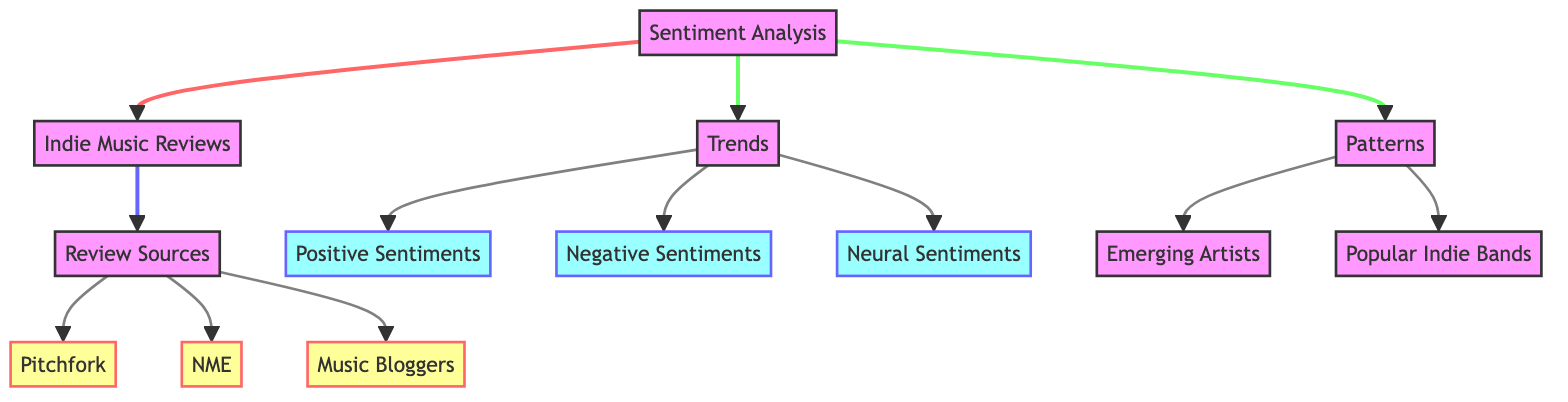What's the main focus of the diagram? The diagram centers on Sentiment Analysis and its relationship with Indie Music Reviews. The central node is "Sentiment Analysis," which connects to "Indie Music Reviews," illustrating this as the primary subject of the analysis.
Answer: Sentiment Analysis How many sources are identified in the diagram? The diagram lists three specific sources under the "Review Sources" node: Pitchfork, NME, and Music Bloggers. By counting these, we find the total to be three.
Answer: 3 What types of sentiments are detailed under "Trends"? Under the "Trends" node, three types of sentiments are indicated: Positive Sentiments, Negative Sentiments, and Neural Sentiments, which indicates the varied emotional evaluations present in the reviews.
Answer: Positive Sentiments, Negative Sentiments, Neural Sentiments What connections exist between "Trends" and "Patterns"? The diagram outlines that "Trends" leads to both "Emerging Artists" and "Popular Indie Bands," while "Patterns" itself is distinct and does not connect back to "Trends," signifying different aspects of music review evaluation.
Answer: Emerging Artists, Popular Indie Bands Which node connects to all review sources? The node "Review Sources" directly connects to three individual sources: Pitchfork, NME, and Music Bloggers, emphasizing the diversity of platforms contributing to the analysis.
Answer: Review Sources What is the relationship between "Trends" and "Patterns"? "Trends" and "Patterns" are distinct concepts explored through sentiment analysis, with "Trends" addressing the types of sentiments and "Patterns" focusing on the outcomes regarding artists. They are both outcomes of the primary node, "Sentiment Analysis."
Answer: Distinct Insights Which sentiment type is classified as neural? In the "Trends" section, "Neural Sentiments" are specified as a form of sentiment. This type is one of the three categories present, indicating neutrality in reviews.
Answer: Neural Sentiments What is the significance of the node "Review Sources"? The "Review Sources" node is pivotal as it categorizes the platforms where the music reviews originate, highlighting the variances in perspectives across different outlets such as Pitchfork, NME, and Music Bloggers.
Answer: Source of Review Perspectives 